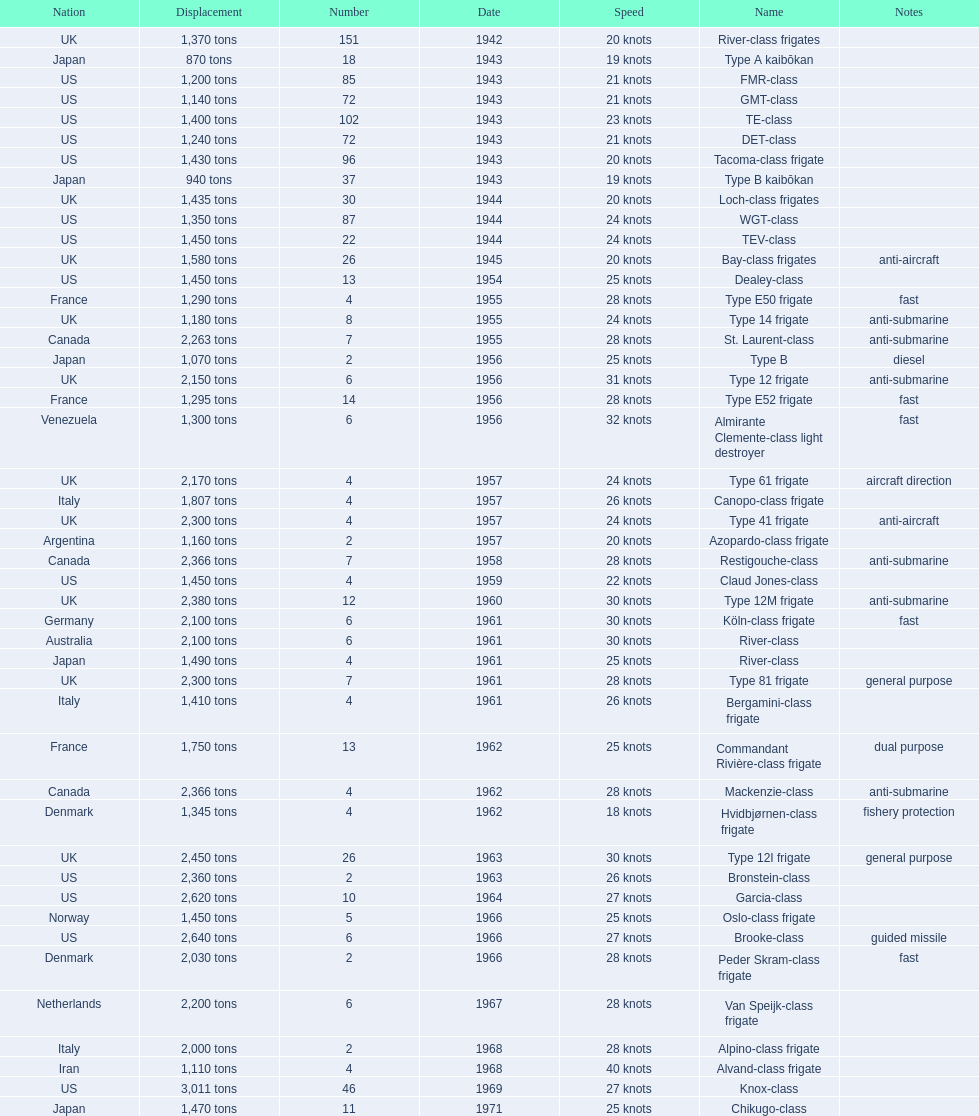What is the difference in speed for the gmt-class and the te-class? 2 knots. 